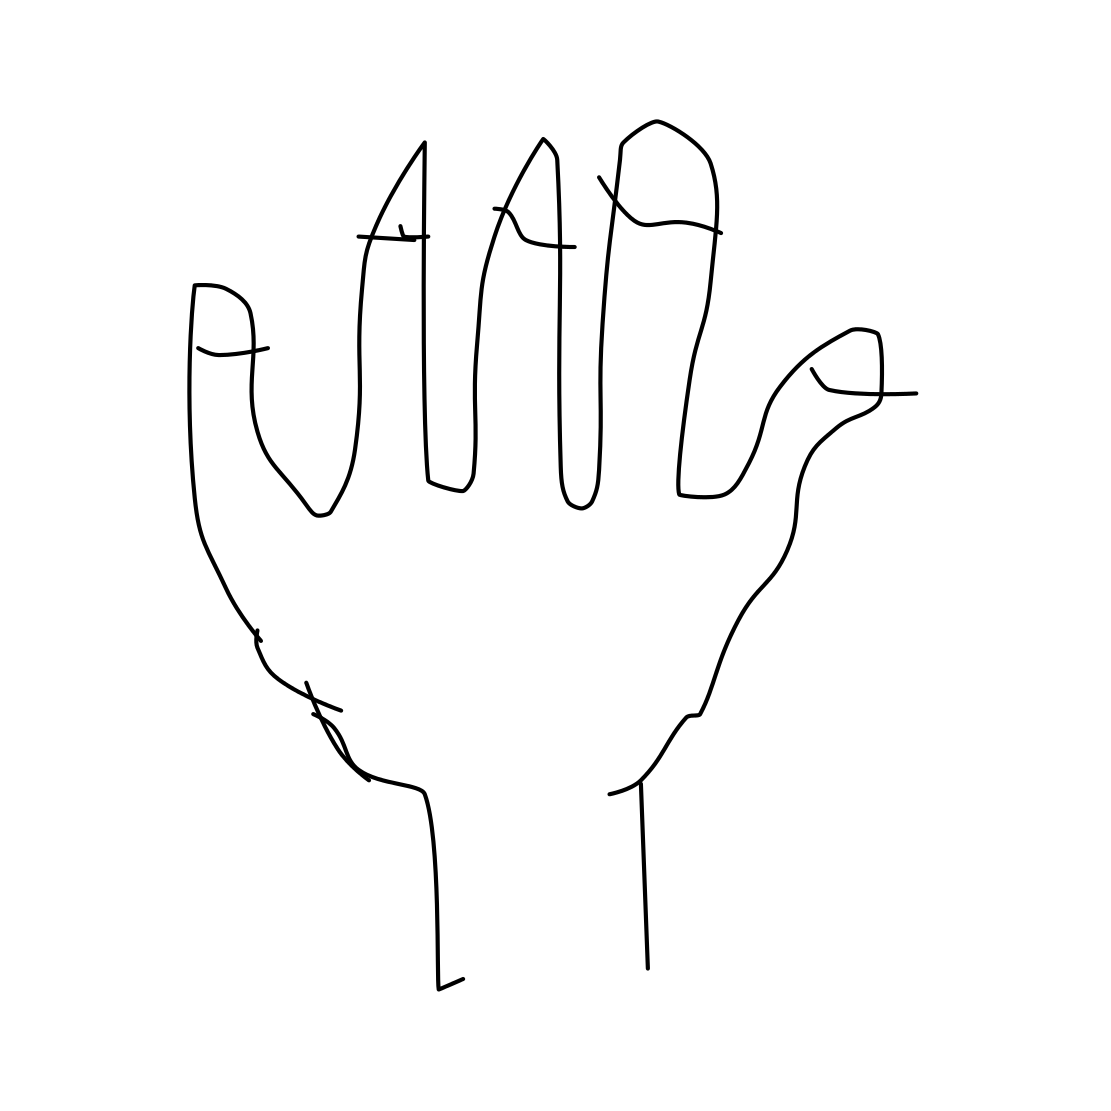What could this drawing be used to illustrate? This line drawing of a hand could be used to illustrate a number of concepts, such as human anatomy for educational purposes, sign language, or even as a part of a symbolic representation in a piece of abstract art. 